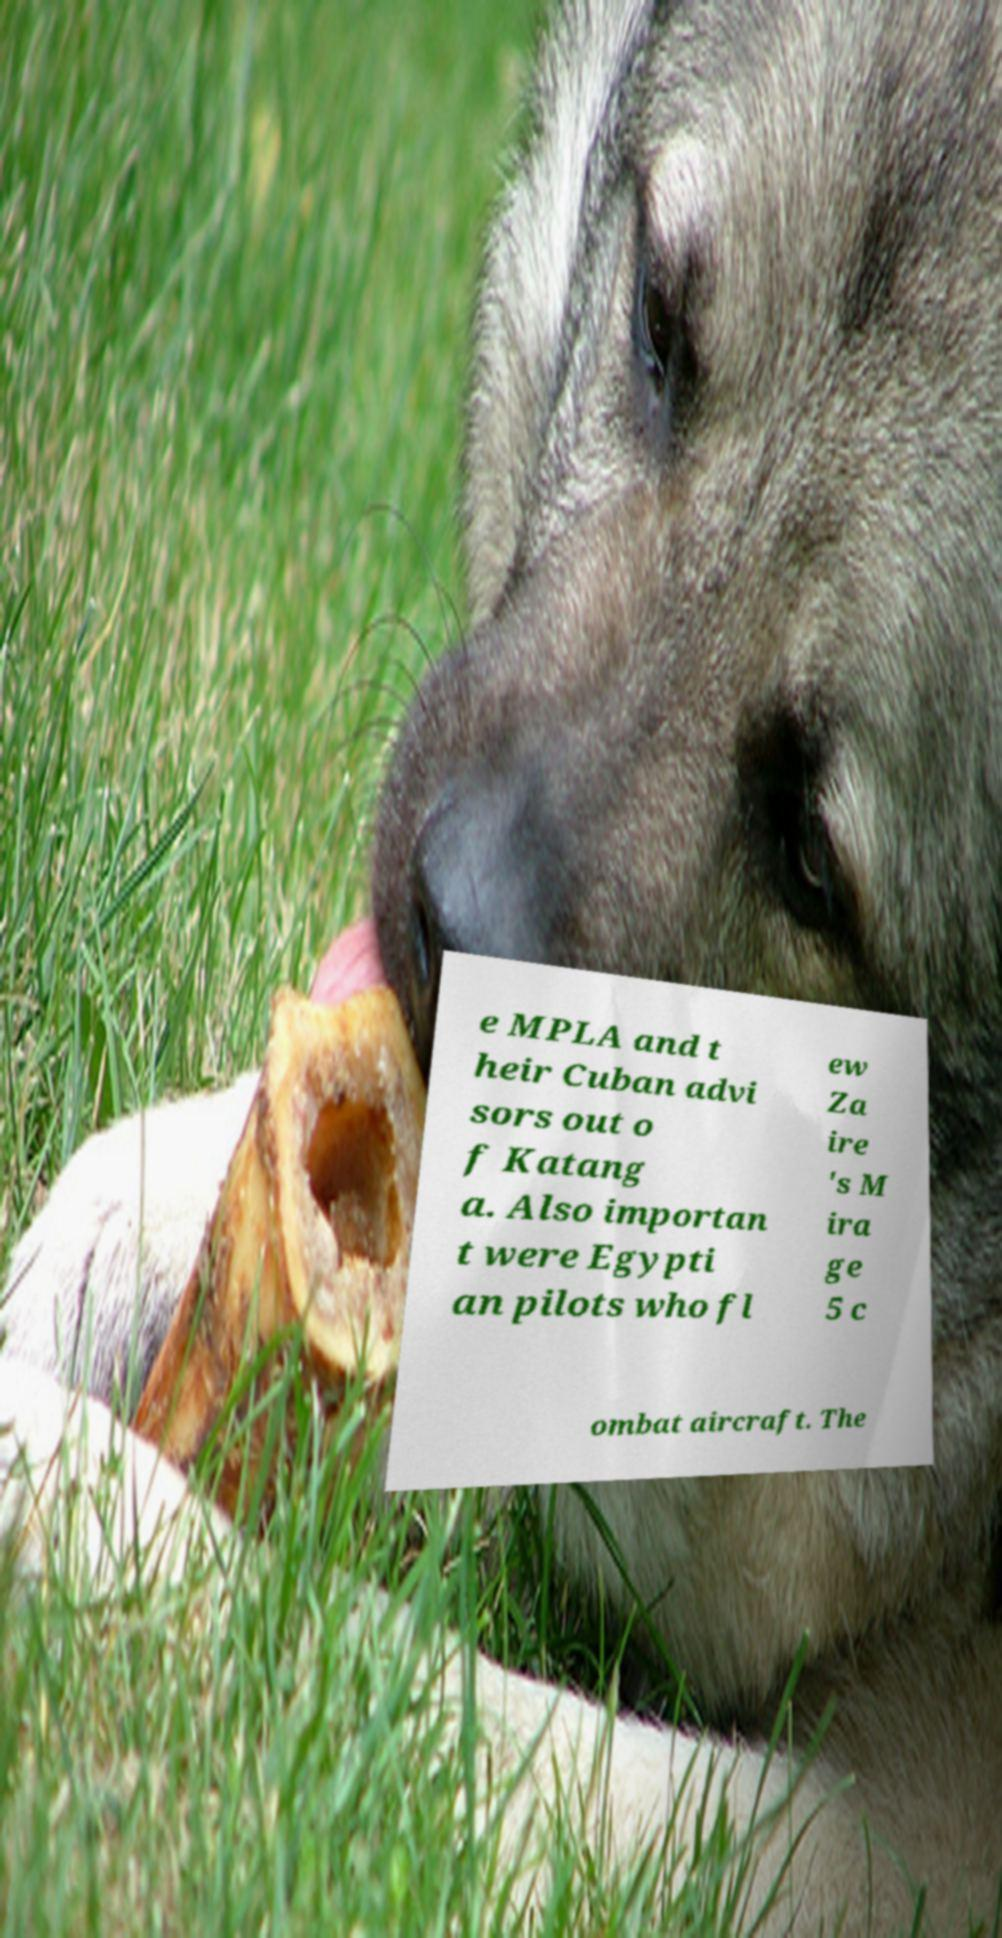Please read and relay the text visible in this image. What does it say? e MPLA and t heir Cuban advi sors out o f Katang a. Also importan t were Egypti an pilots who fl ew Za ire 's M ira ge 5 c ombat aircraft. The 